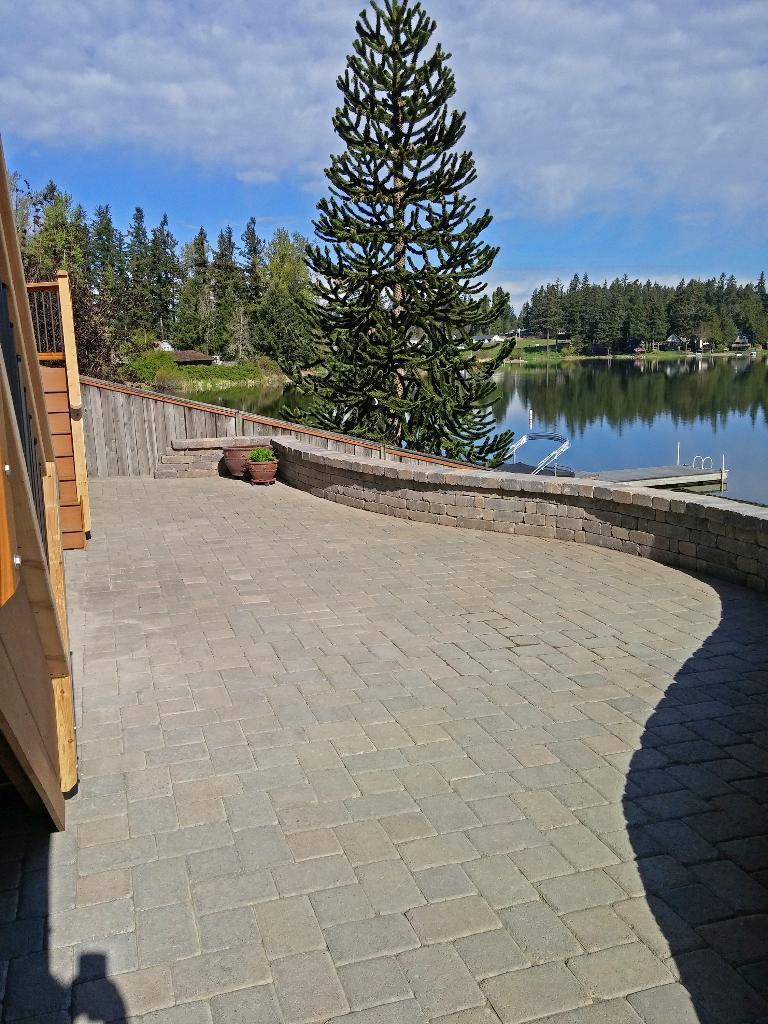Please provide a concise description of this image. In the center of the image there is a wall and plant pots. On the left side of the image, we can see wooden staircases and fences. In the background, we can see the sky, clouds, trees, poles, water, buildings etc. 